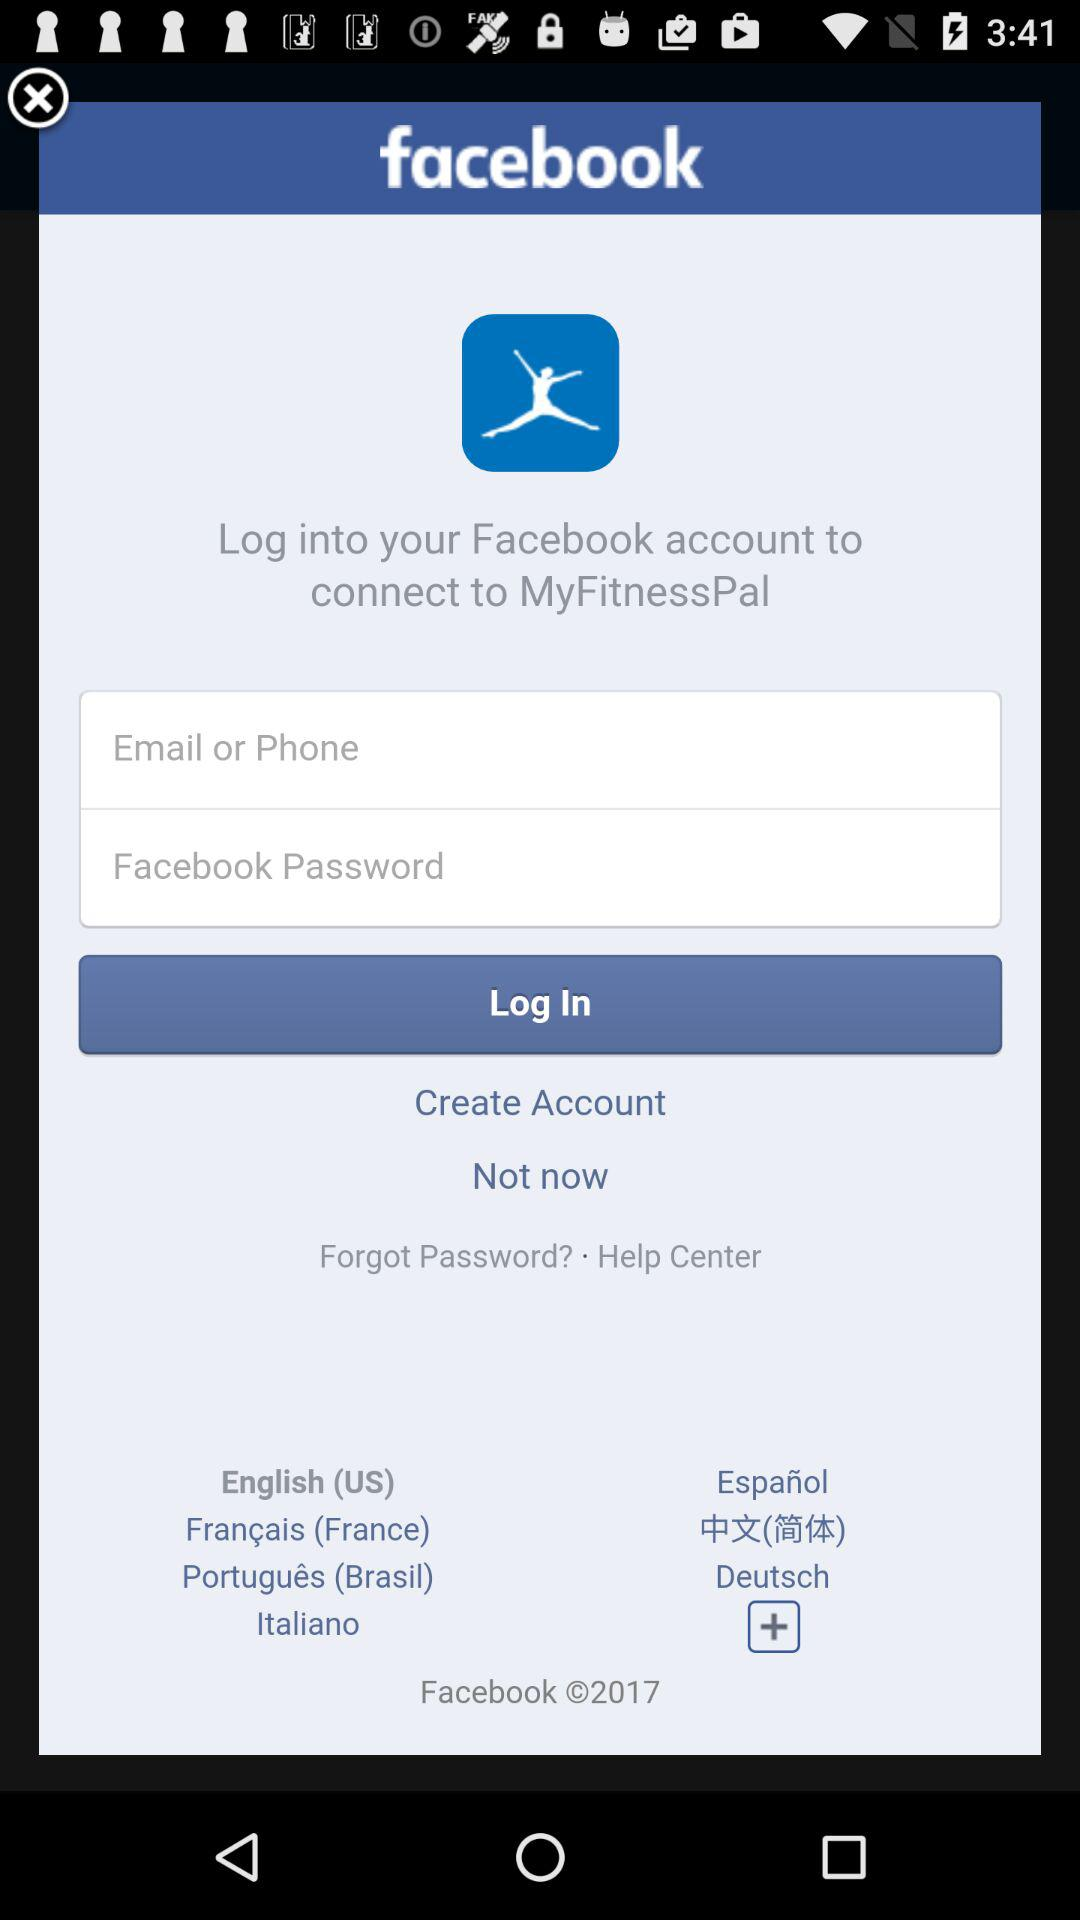How can we login? We can login through Facebook. 